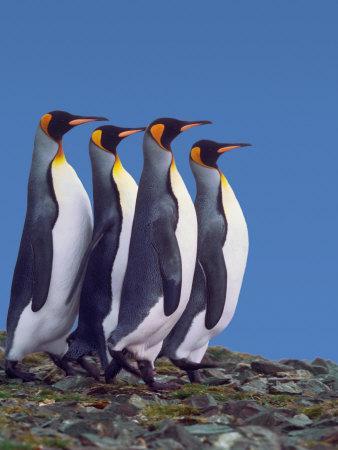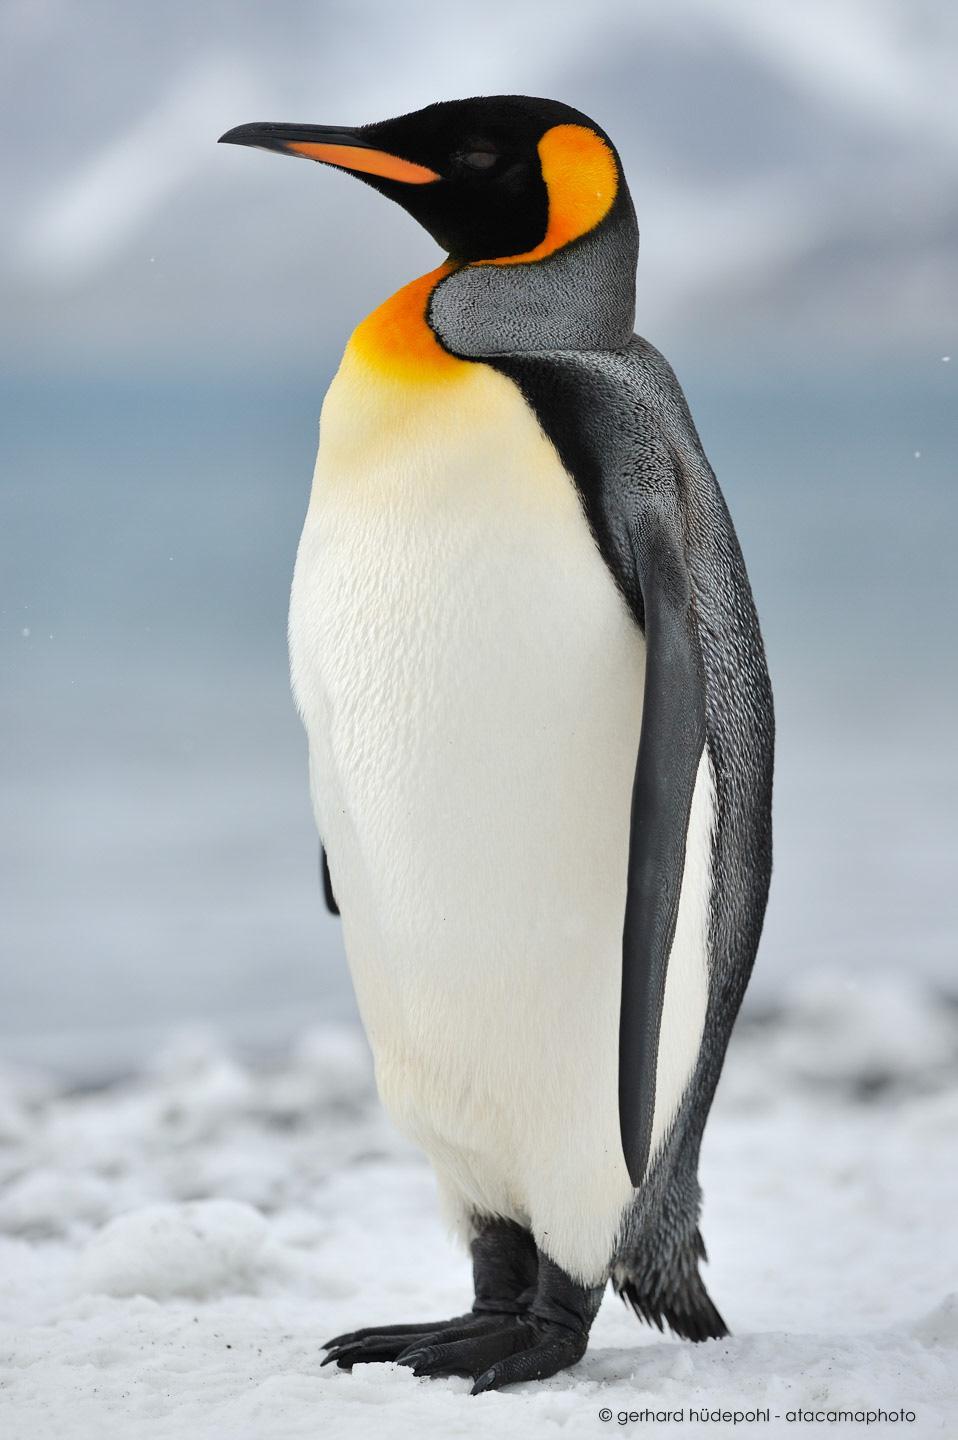The first image is the image on the left, the second image is the image on the right. Evaluate the accuracy of this statement regarding the images: "There is exactly one penguin in the image on the right.". Is it true? Answer yes or no. Yes. 